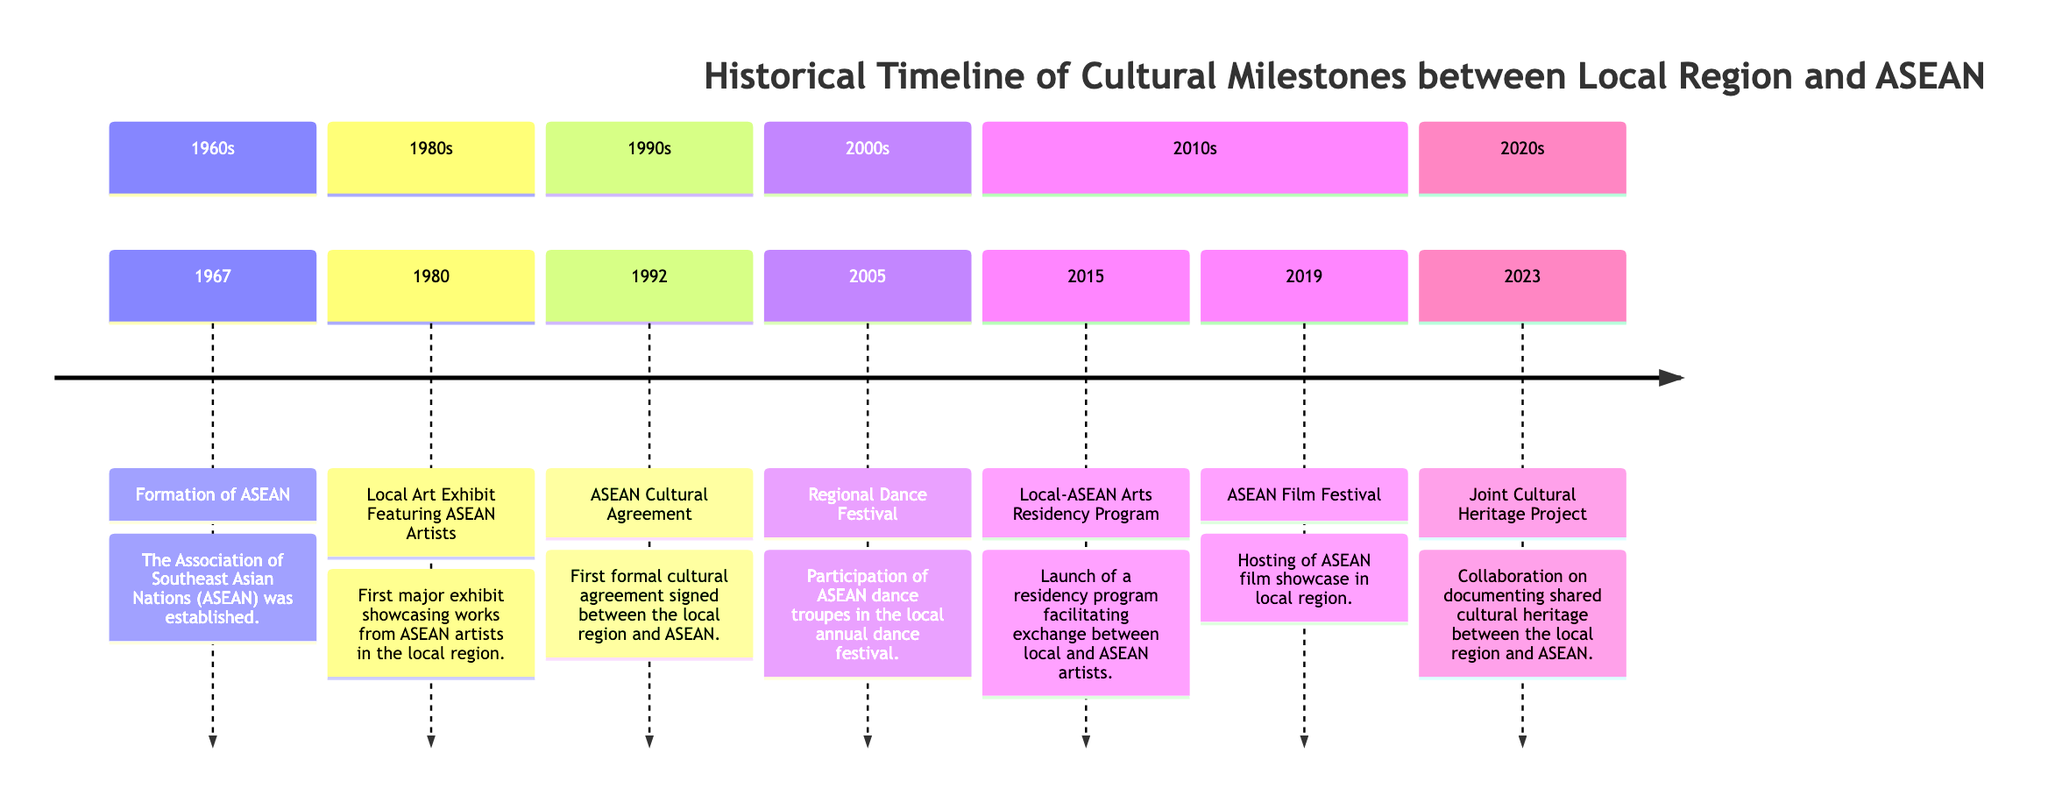What year was ASEAN established? The diagram shows the event "Formation of ASEAN" is linked to the year 1967, indicating the establishment date of ASEAN.
Answer: 1967 What significant cultural event occurred in 1980? The diagram lists "Local Art Exhibit Featuring ASEAN Artists" in the year 1980 as a major cultural event showcasing ASEAN artists.
Answer: Local Art Exhibit Featuring ASEAN Artists In which decade was the ASEAN Cultural Agreement signed? The diagram indicates that the "ASEAN Cultural Agreement" event is placed in the 1990s, so that is the decade of its occurrence.
Answer: 1990s How many cultural milestones are listed in the 2010s section? Reviewing the 2010s section of the diagram reveals two milestones: "Local-ASEAN Arts Residency Program" and "ASEAN Film Festival." Therefore, the count is 2.
Answer: 2 Which milestone occurred just before the Joint Cultural Heritage Project? To find the answer, we look at the 2023 entry for "Joint Cultural Heritage Project," which follows "ASEAN Film Festival" in 2019. So the milestone directly before it is the ASEAN Film Festival.
Answer: ASEAN Film Festival What was the purpose of the Local-ASEAN Arts Residency Program? The diagram mentions it as a program that facilitates exchange between local and ASEAN artists, indicating its purpose clearly.
Answer: Facilitate exchange between local and ASEAN artists Which cultural milestone occurred in 2005? The event "Regional Dance Festival" is explicitly mentioned alongside the year 2005 in the diagram.
Answer: Regional Dance Festival How many total cultural milestones are depicted in the diagram? By counting each section in the diagram and identifying the milestones, there are a total of 7 milestones shown for the years presented in the timeline.
Answer: 7 Which milestone represents a collaboration on shared cultural heritage? The "Joint Cultural Heritage Project" listed for the year 2023 is specifically highlighting the theme of collaboration on documenting shared cultural heritage.
Answer: Joint Cultural Heritage Project 